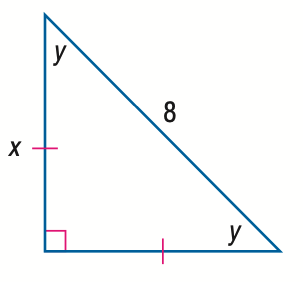Answer the mathemtical geometry problem and directly provide the correct option letter.
Question: Find y.
Choices: A: 30 B: 45 C: 60 D: 90 B 